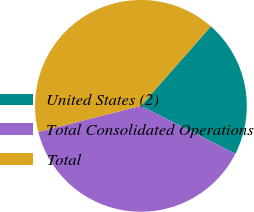Convert chart. <chart><loc_0><loc_0><loc_500><loc_500><pie_chart><fcel>United States (2)<fcel>Total Consolidated Operations<fcel>Total<nl><fcel>20.99%<fcel>38.57%<fcel>40.45%<nl></chart> 